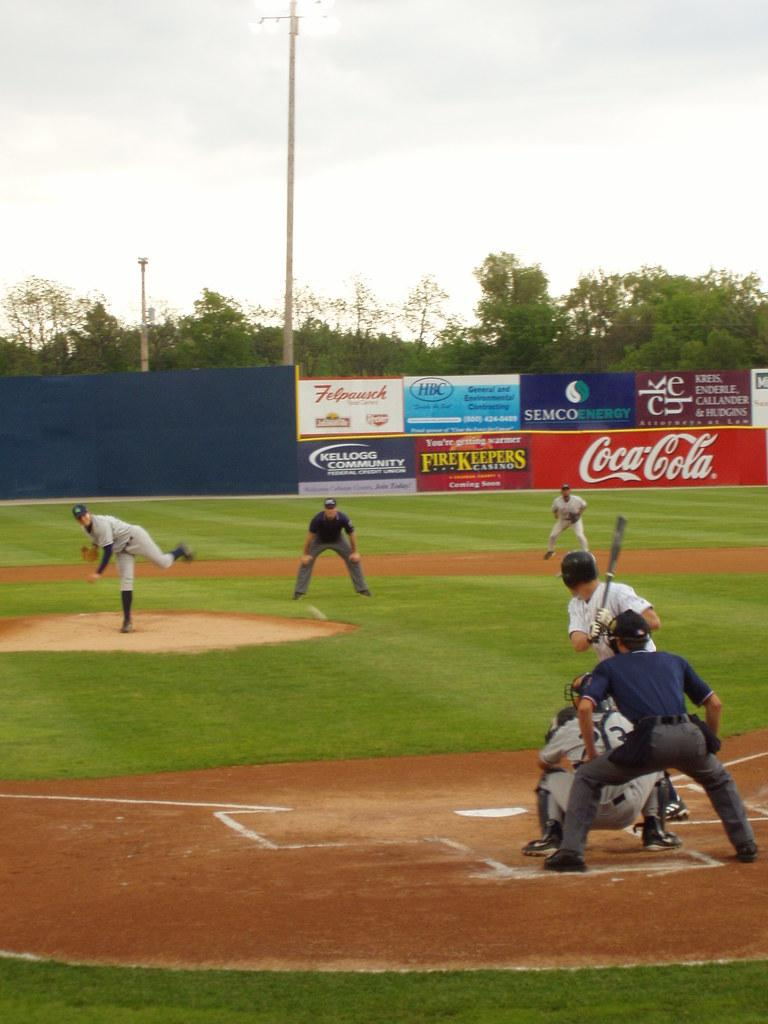Provide a one-sentence caption for the provided image. People playing baseball in a park with Coca Cola ads. 